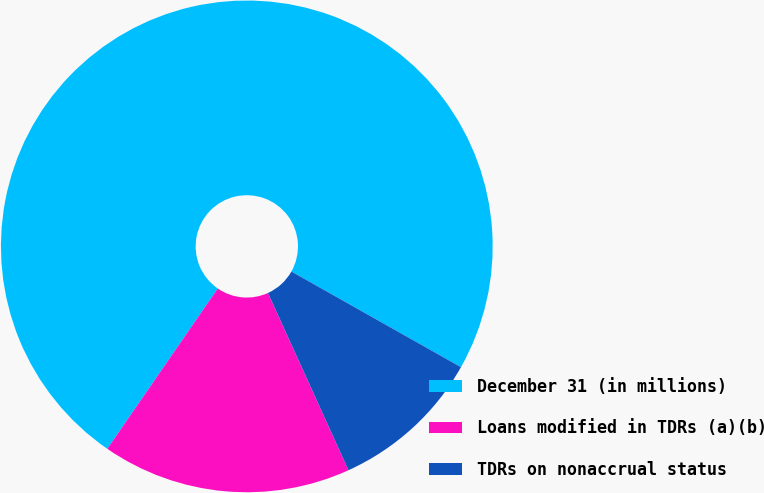Convert chart to OTSL. <chart><loc_0><loc_0><loc_500><loc_500><pie_chart><fcel>December 31 (in millions)<fcel>Loans modified in TDRs (a)(b)<fcel>TDRs on nonaccrual status<nl><fcel>73.57%<fcel>16.39%<fcel>10.04%<nl></chart> 